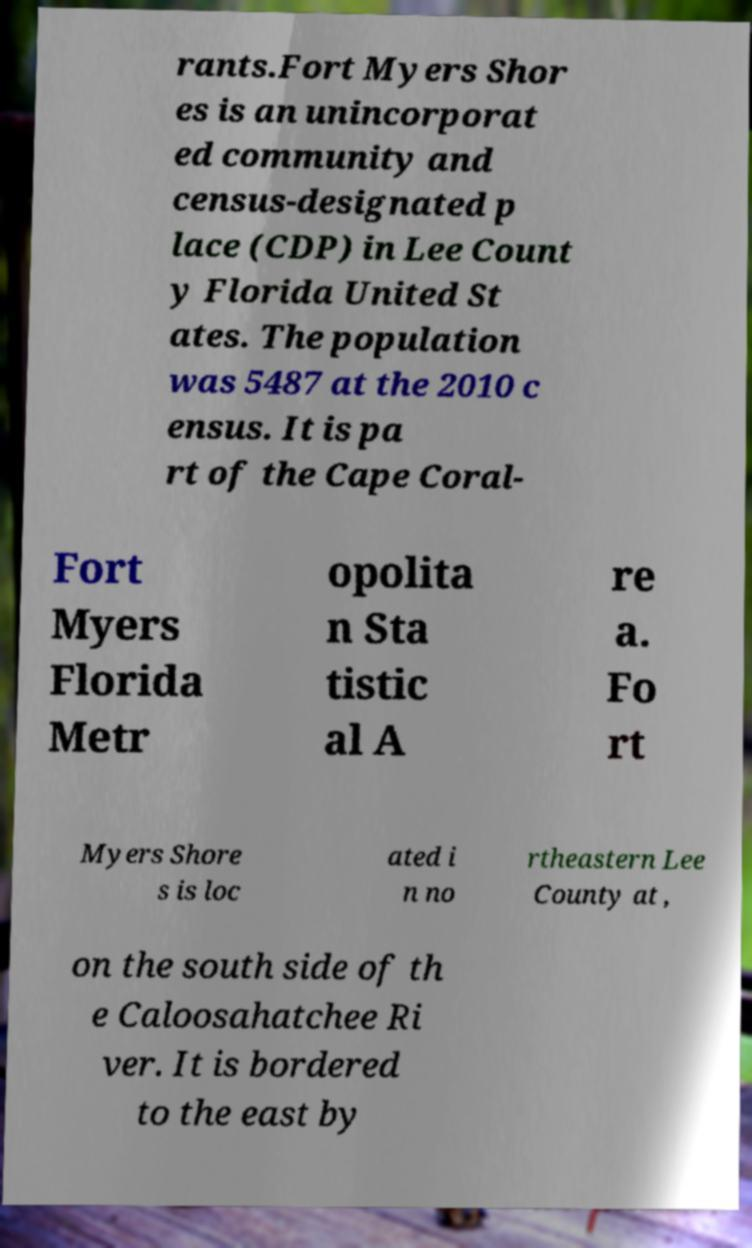Please identify and transcribe the text found in this image. rants.Fort Myers Shor es is an unincorporat ed community and census-designated p lace (CDP) in Lee Count y Florida United St ates. The population was 5487 at the 2010 c ensus. It is pa rt of the Cape Coral- Fort Myers Florida Metr opolita n Sta tistic al A re a. Fo rt Myers Shore s is loc ated i n no rtheastern Lee County at , on the south side of th e Caloosahatchee Ri ver. It is bordered to the east by 